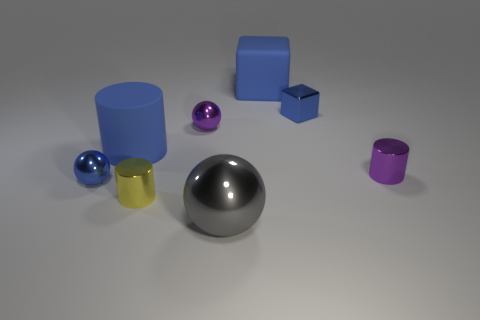Subtract all blue blocks. How many were subtracted if there are1blue blocks left? 1 Subtract all big cylinders. How many cylinders are left? 2 Subtract all blue balls. How many balls are left? 2 Subtract all cylinders. How many objects are left? 5 Subtract 1 blocks. How many blocks are left? 1 Subtract all blue cylinders. Subtract all yellow balls. How many cylinders are left? 2 Subtract all blue cubes. How many blue cylinders are left? 1 Subtract all small yellow metallic cylinders. Subtract all small objects. How many objects are left? 2 Add 8 blue spheres. How many blue spheres are left? 9 Add 8 yellow shiny objects. How many yellow shiny objects exist? 9 